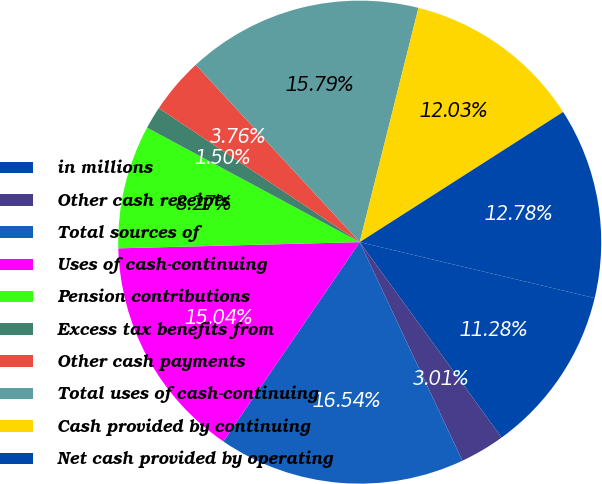Convert chart. <chart><loc_0><loc_0><loc_500><loc_500><pie_chart><fcel>in millions<fcel>Other cash receipts<fcel>Total sources of<fcel>Uses of cash-continuing<fcel>Pension contributions<fcel>Excess tax benefits from<fcel>Other cash payments<fcel>Total uses of cash-continuing<fcel>Cash provided by continuing<fcel>Net cash provided by operating<nl><fcel>11.28%<fcel>3.01%<fcel>16.54%<fcel>15.04%<fcel>8.27%<fcel>1.5%<fcel>3.76%<fcel>15.79%<fcel>12.03%<fcel>12.78%<nl></chart> 